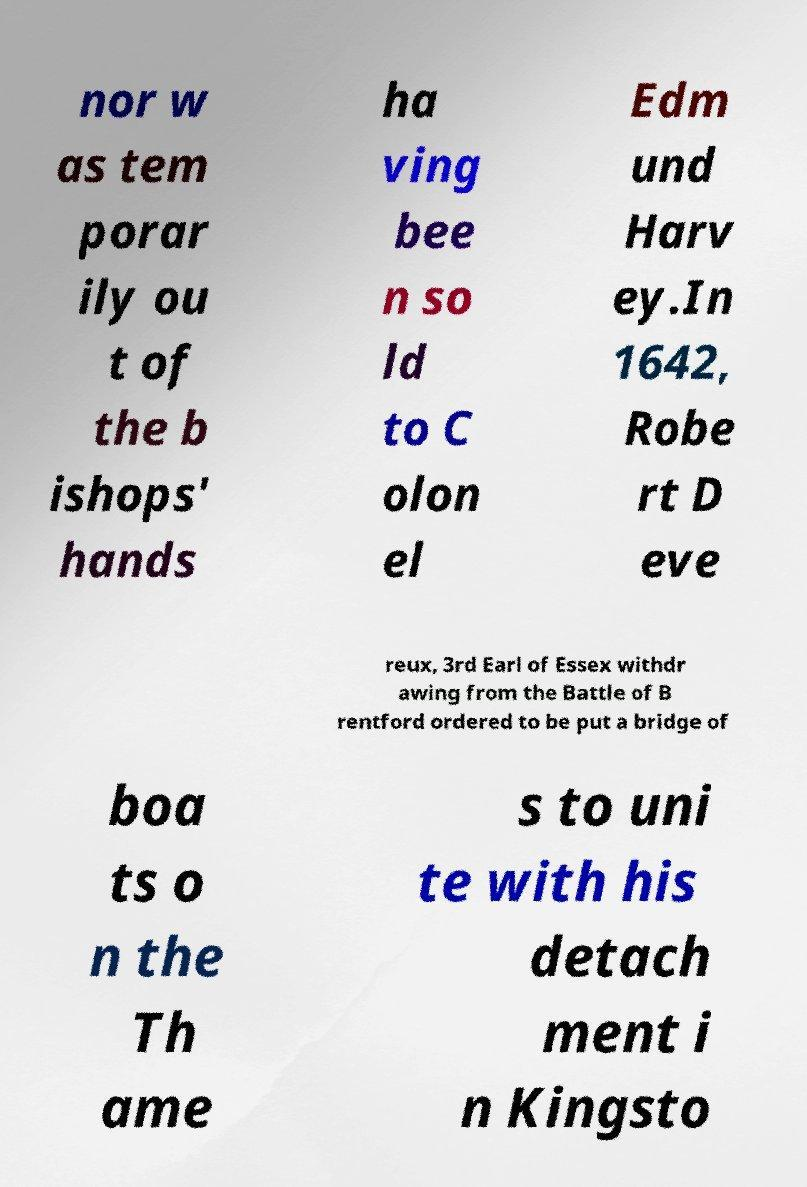Can you read and provide the text displayed in the image?This photo seems to have some interesting text. Can you extract and type it out for me? nor w as tem porar ily ou t of the b ishops' hands ha ving bee n so ld to C olon el Edm und Harv ey.In 1642, Robe rt D eve reux, 3rd Earl of Essex withdr awing from the Battle of B rentford ordered to be put a bridge of boa ts o n the Th ame s to uni te with his detach ment i n Kingsto 